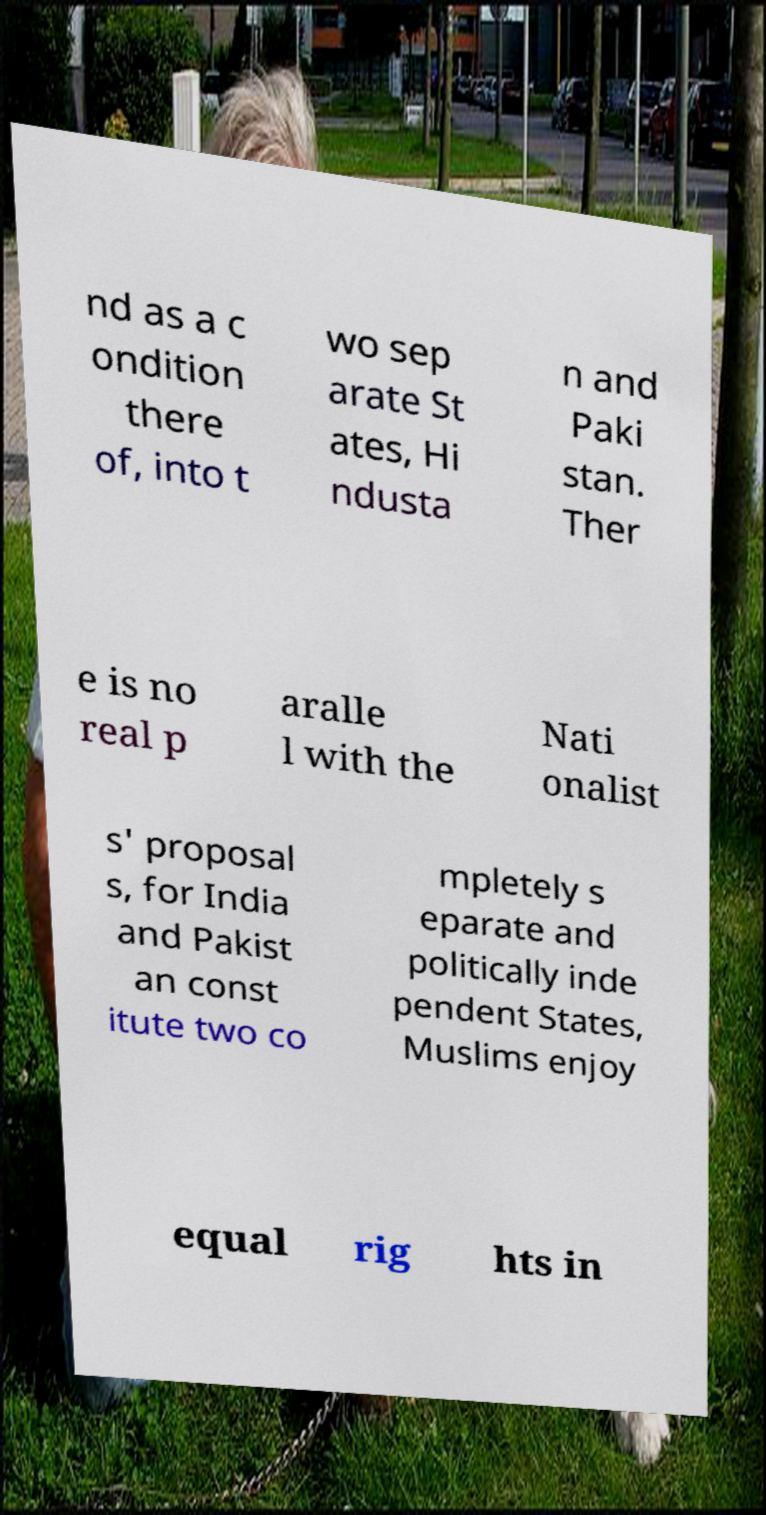Can you accurately transcribe the text from the provided image for me? nd as a c ondition there of, into t wo sep arate St ates, Hi ndusta n and Paki stan. Ther e is no real p aralle l with the Nati onalist s' proposal s, for India and Pakist an const itute two co mpletely s eparate and politically inde pendent States, Muslims enjoy equal rig hts in 